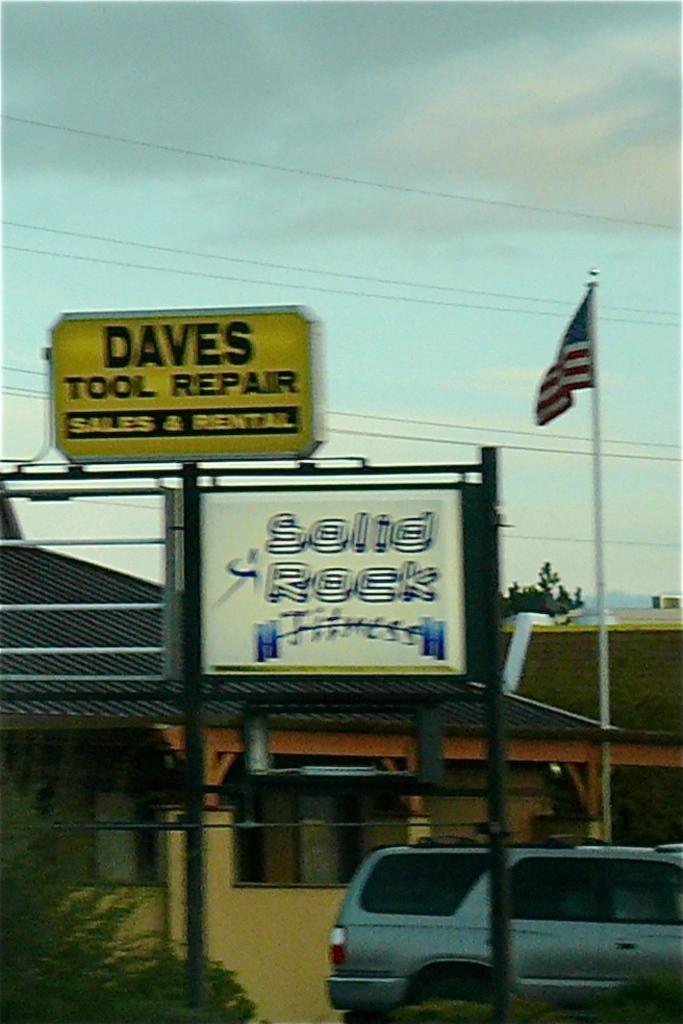Please provide a concise description of this image. In this picture we can see few houses, hoardings, plants and a car, in the background we can see a tree and clouds, on the right side of the image we can see a flag. 